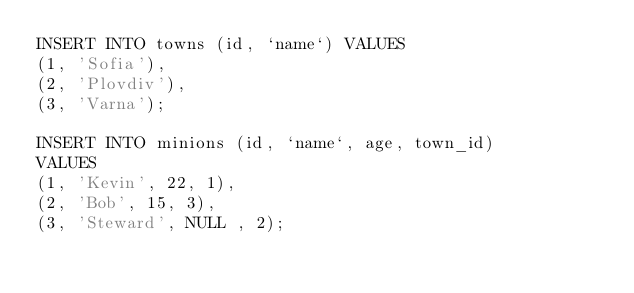<code> <loc_0><loc_0><loc_500><loc_500><_SQL_>INSERT INTO towns (id, `name`) VALUES 
(1, 'Sofia'),
(2, 'Plovdiv'),
(3, 'Varna');

INSERT INTO minions (id, `name`, age, town_id)
VALUES 
(1, 'Kevin', 22, 1),
(2, 'Bob', 15, 3),
(3, 'Steward', NULL , 2);</code> 